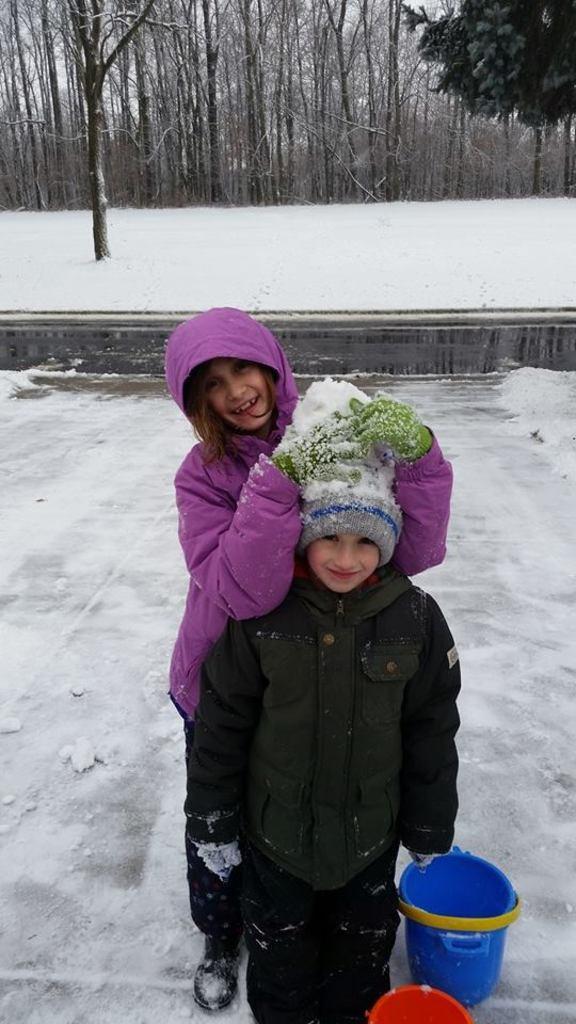Describe this image in one or two sentences. In this image two kids are standing on the floor, which is covered with snow. Right bottom there are two buckets. Background there are few trees on the land which is covered with snow. 